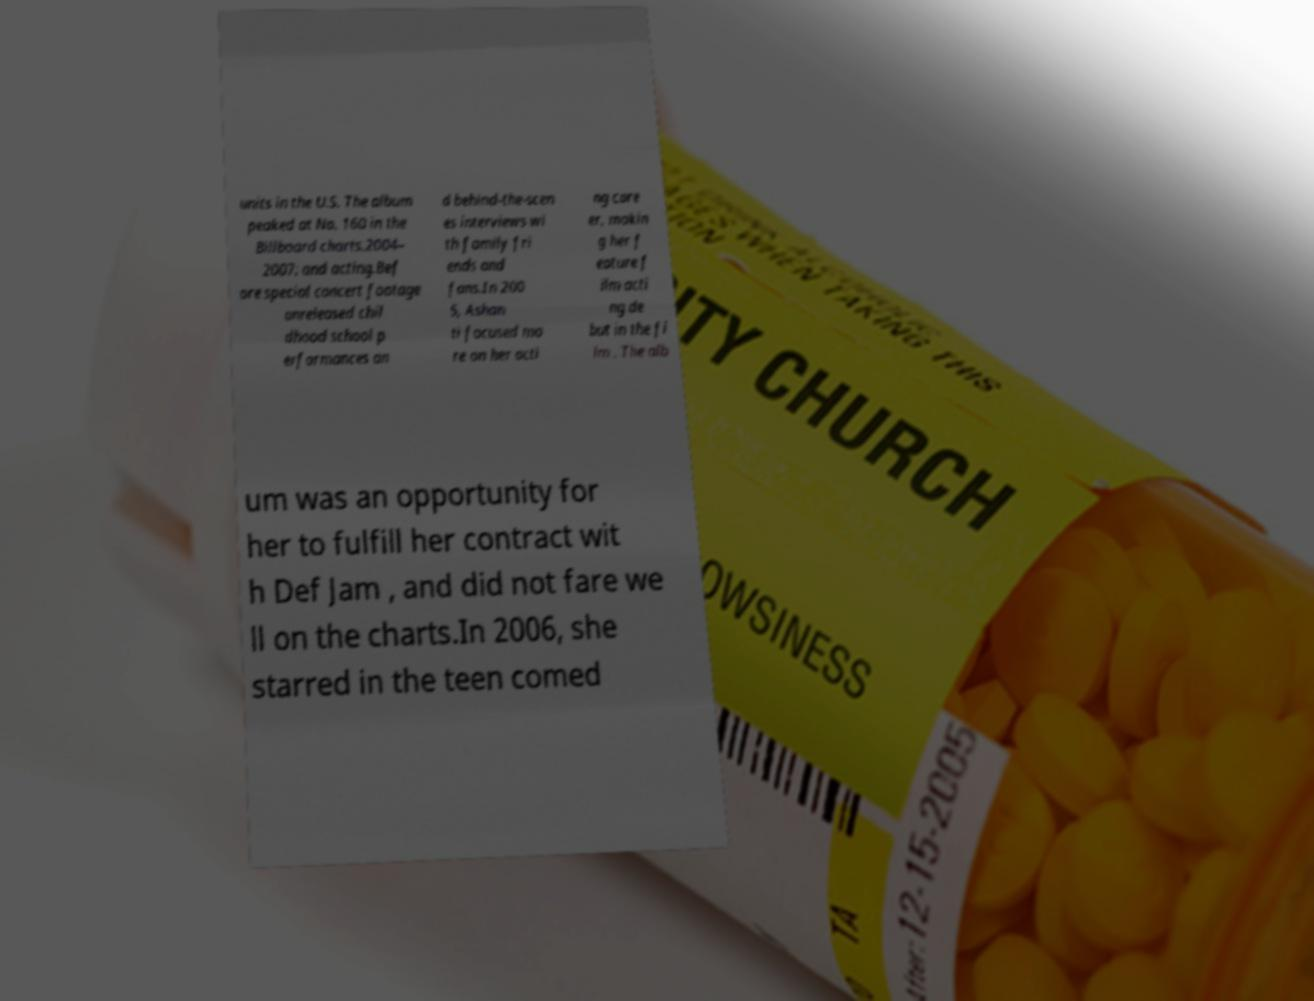Can you accurately transcribe the text from the provided image for me? units in the U.S. The album peaked at No. 160 in the Billboard charts.2004– 2007: and acting.Bef ore special concert footage unreleased chil dhood school p erformances an d behind-the-scen es interviews wi th family fri ends and fans.In 200 5, Ashan ti focused mo re on her acti ng care er, makin g her f eature f ilm acti ng de but in the fi lm . The alb um was an opportunity for her to fulfill her contract wit h Def Jam , and did not fare we ll on the charts.In 2006, she starred in the teen comed 